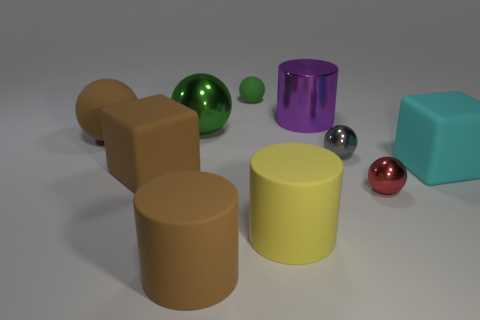Subtract 1 balls. How many balls are left? 4 Subtract all gray balls. How many balls are left? 4 Subtract all gray balls. How many balls are left? 4 Subtract all blue balls. Subtract all red cylinders. How many balls are left? 5 Subtract all cubes. How many objects are left? 8 Add 8 tiny blue metal balls. How many tiny blue metal balls exist? 8 Subtract 1 brown spheres. How many objects are left? 9 Subtract all tiny blue matte cylinders. Subtract all cyan matte cubes. How many objects are left? 9 Add 6 green metallic balls. How many green metallic balls are left? 7 